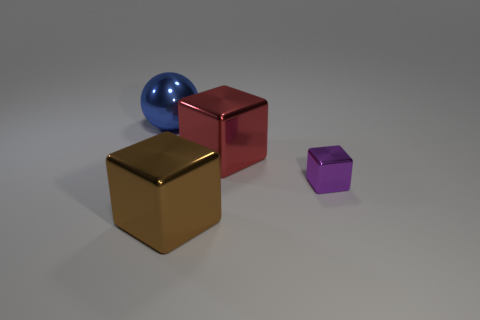What number of cubes are either tiny purple objects or big brown things?
Your answer should be very brief. 2. The big metal thing that is both behind the big brown object and in front of the blue shiny ball has what shape?
Offer a terse response. Cube. There is a large thing in front of the cube right of the large object that is right of the large brown metallic object; what color is it?
Offer a terse response. Brown. Is the number of purple metal blocks that are right of the large brown metal block less than the number of large yellow blocks?
Ensure brevity in your answer.  No. There is a metal thing that is in front of the purple shiny thing; does it have the same shape as the thing right of the red metallic object?
Make the answer very short. Yes. How many things are either large blocks on the right side of the big brown object or tiny metallic cylinders?
Make the answer very short. 1. Are there any metallic things that are on the right side of the large object that is right of the block that is in front of the small purple shiny block?
Make the answer very short. Yes. Are there fewer big brown metallic cubes that are to the right of the brown shiny block than big blue shiny spheres behind the small metal object?
Make the answer very short. Yes. What color is the tiny cube that is the same material as the large blue thing?
Give a very brief answer. Purple. What is the color of the large object that is right of the shiny thing that is in front of the small shiny cube?
Your answer should be very brief. Red. 